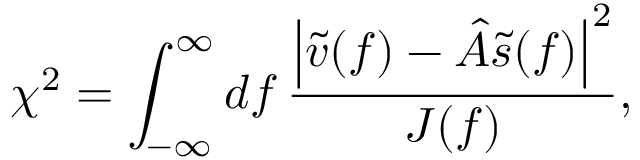Convert formula to latex. <formula><loc_0><loc_0><loc_500><loc_500>\chi ^ { 2 } = \int _ { - \infty } ^ { \infty } d f \frac { \left | \tilde { v } ( f ) - \hat { A } \tilde { s } ( f ) \right | ^ { 2 } } { J ( f ) } ,</formula> 